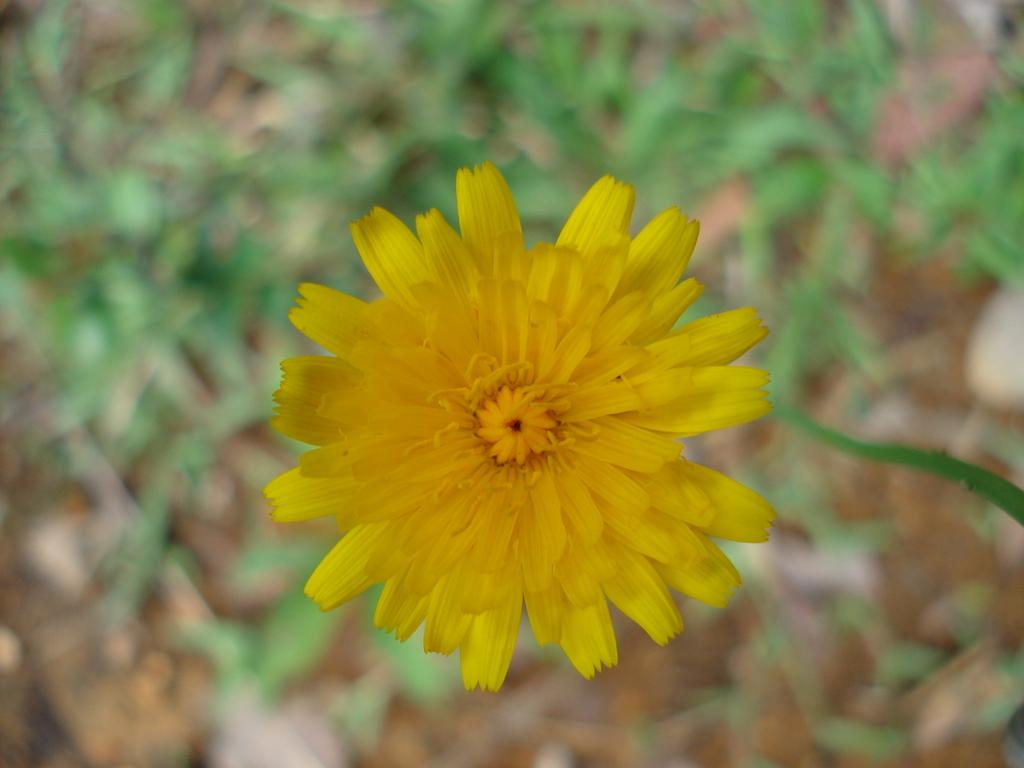What type of flower is present in the image? There is a yellow color flower in the image. Can you describe the background of the image? The background of the image is blurry. What type of sheet is used to cover the kettle in the image? There is no sheet or kettle present in the image; it only features a yellow color flower with a blurry background. 